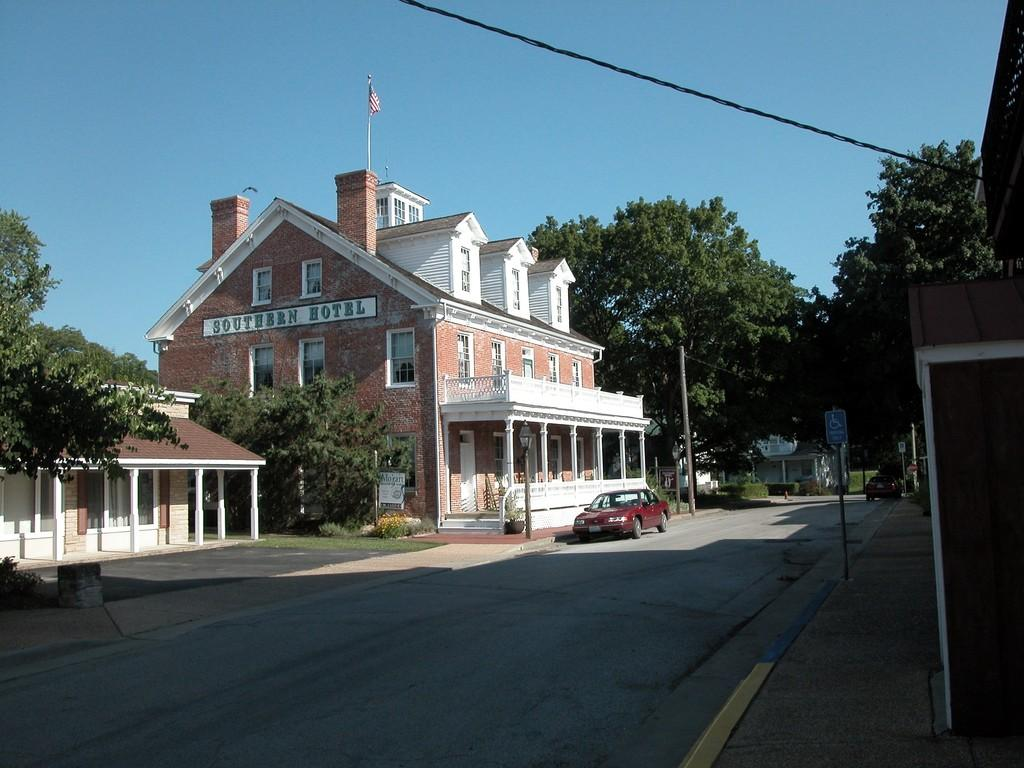What type of structures can be seen in the image? There are buildings in the image. What other natural elements are present in the image? There are trees in the image. Is there any transportation visible in the image? Yes, there is a car parked on the road in the image. How many needles are there in the image? There are no needles present in the image. What type of ball can be seen bouncing in the image? There is no ball present in the image. 